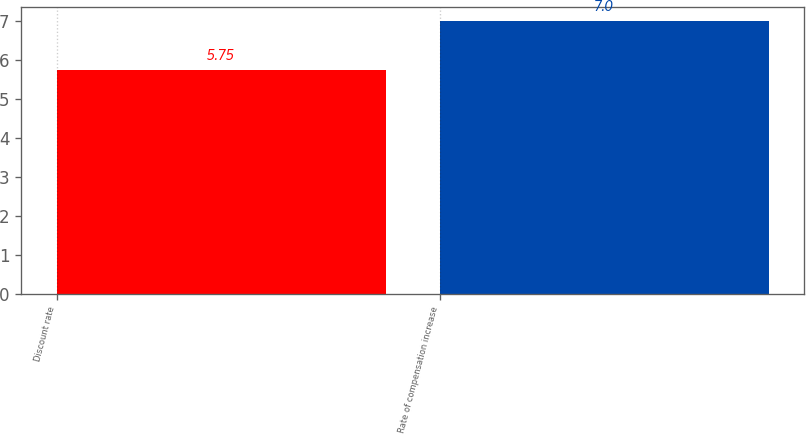Convert chart. <chart><loc_0><loc_0><loc_500><loc_500><bar_chart><fcel>Discount rate<fcel>Rate of compensation increase<nl><fcel>5.75<fcel>7<nl></chart> 